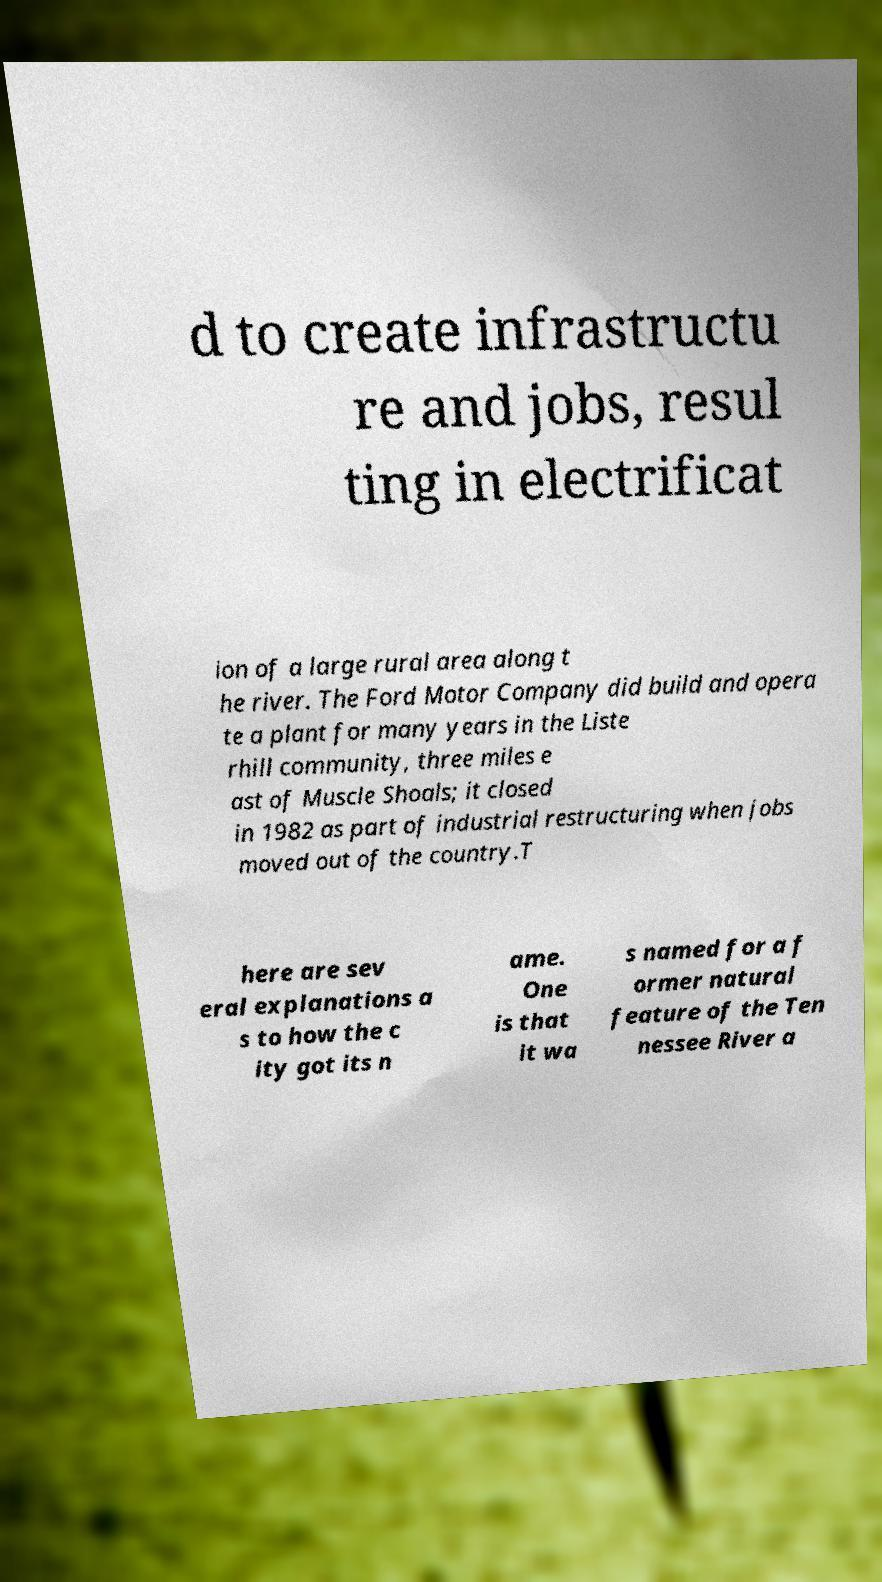What messages or text are displayed in this image? I need them in a readable, typed format. d to create infrastructu re and jobs, resul ting in electrificat ion of a large rural area along t he river. The Ford Motor Company did build and opera te a plant for many years in the Liste rhill community, three miles e ast of Muscle Shoals; it closed in 1982 as part of industrial restructuring when jobs moved out of the country.T here are sev eral explanations a s to how the c ity got its n ame. One is that it wa s named for a f ormer natural feature of the Ten nessee River a 